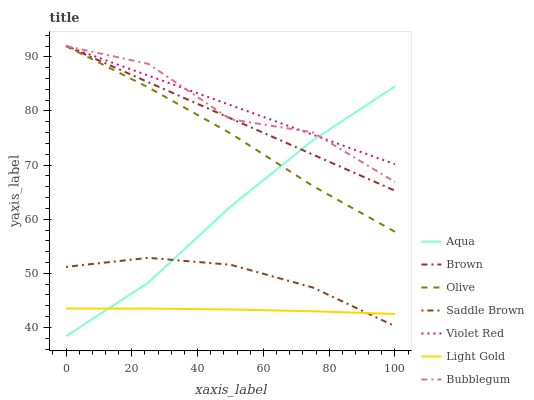Does Light Gold have the minimum area under the curve?
Answer yes or no. Yes. Does Violet Red have the maximum area under the curve?
Answer yes or no. Yes. Does Aqua have the minimum area under the curve?
Answer yes or no. No. Does Aqua have the maximum area under the curve?
Answer yes or no. No. Is Violet Red the smoothest?
Answer yes or no. Yes. Is Bubblegum the roughest?
Answer yes or no. Yes. Is Aqua the smoothest?
Answer yes or no. No. Is Aqua the roughest?
Answer yes or no. No. Does Aqua have the lowest value?
Answer yes or no. Yes. Does Violet Red have the lowest value?
Answer yes or no. No. Does Olive have the highest value?
Answer yes or no. Yes. Does Aqua have the highest value?
Answer yes or no. No. Is Light Gold less than Violet Red?
Answer yes or no. Yes. Is Violet Red greater than Light Gold?
Answer yes or no. Yes. Does Violet Red intersect Aqua?
Answer yes or no. Yes. Is Violet Red less than Aqua?
Answer yes or no. No. Is Violet Red greater than Aqua?
Answer yes or no. No. Does Light Gold intersect Violet Red?
Answer yes or no. No. 